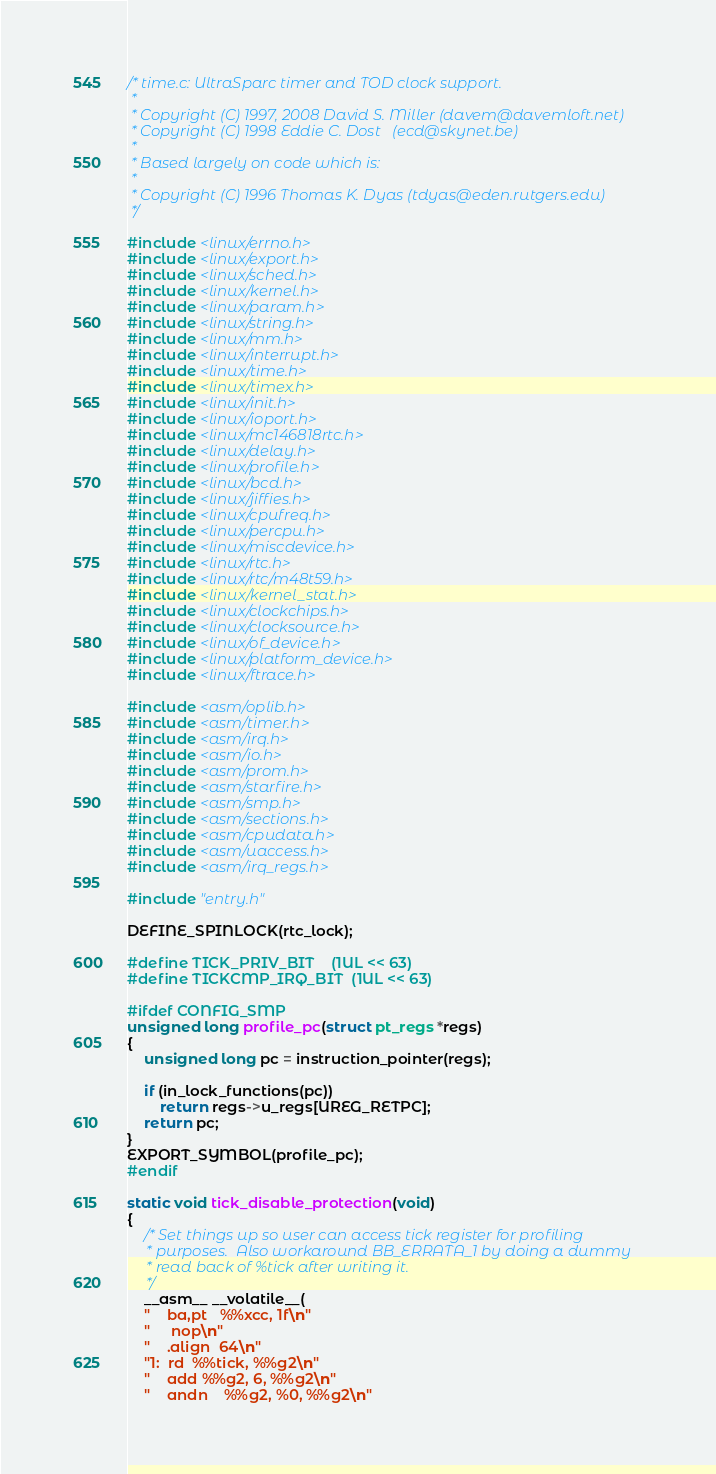<code> <loc_0><loc_0><loc_500><loc_500><_C_>/* time.c: UltraSparc timer and TOD clock support.
 *
 * Copyright (C) 1997, 2008 David S. Miller (davem@davemloft.net)
 * Copyright (C) 1998 Eddie C. Dost   (ecd@skynet.be)
 *
 * Based largely on code which is:
 *
 * Copyright (C) 1996 Thomas K. Dyas (tdyas@eden.rutgers.edu)
 */

#include <linux/errno.h>
#include <linux/export.h>
#include <linux/sched.h>
#include <linux/kernel.h>
#include <linux/param.h>
#include <linux/string.h>
#include <linux/mm.h>
#include <linux/interrupt.h>
#include <linux/time.h>
#include <linux/timex.h>
#include <linux/init.h>
#include <linux/ioport.h>
#include <linux/mc146818rtc.h>
#include <linux/delay.h>
#include <linux/profile.h>
#include <linux/bcd.h>
#include <linux/jiffies.h>
#include <linux/cpufreq.h>
#include <linux/percpu.h>
#include <linux/miscdevice.h>
#include <linux/rtc.h>
#include <linux/rtc/m48t59.h>
#include <linux/kernel_stat.h>
#include <linux/clockchips.h>
#include <linux/clocksource.h>
#include <linux/of_device.h>
#include <linux/platform_device.h>
#include <linux/ftrace.h>

#include <asm/oplib.h>
#include <asm/timer.h>
#include <asm/irq.h>
#include <asm/io.h>
#include <asm/prom.h>
#include <asm/starfire.h>
#include <asm/smp.h>
#include <asm/sections.h>
#include <asm/cpudata.h>
#include <asm/uaccess.h>
#include <asm/irq_regs.h>

#include "entry.h"

DEFINE_SPINLOCK(rtc_lock);

#define TICK_PRIV_BIT	(1UL << 63)
#define TICKCMP_IRQ_BIT	(1UL << 63)

#ifdef CONFIG_SMP
unsigned long profile_pc(struct pt_regs *regs)
{
	unsigned long pc = instruction_pointer(regs);

	if (in_lock_functions(pc))
		return regs->u_regs[UREG_RETPC];
	return pc;
}
EXPORT_SYMBOL(profile_pc);
#endif

static void tick_disable_protection(void)
{
	/* Set things up so user can access tick register for profiling
	 * purposes.  Also workaround BB_ERRATA_1 by doing a dummy
	 * read back of %tick after writing it.
	 */
	__asm__ __volatile__(
	"	ba,pt	%%xcc, 1f\n"
	"	 nop\n"
	"	.align	64\n"
	"1:	rd	%%tick, %%g2\n"
	"	add	%%g2, 6, %%g2\n"
	"	andn	%%g2, %0, %%g2\n"</code> 